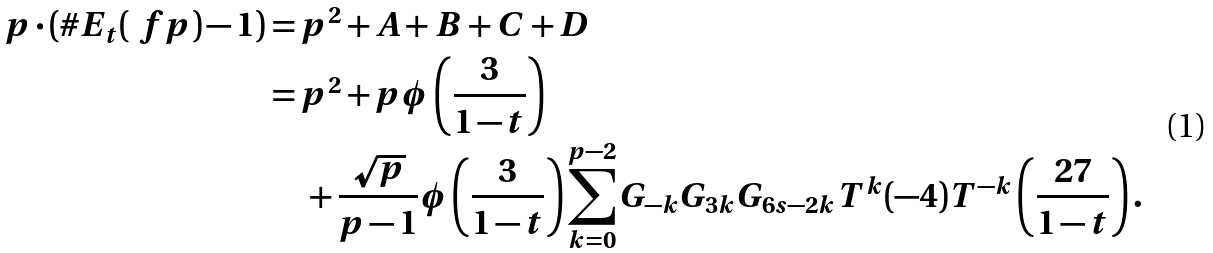Convert formula to latex. <formula><loc_0><loc_0><loc_500><loc_500>p \cdot ( \# E _ { t } ( \ f p ) - 1 ) & = p ^ { 2 } + A + B + C + D \\ & = p ^ { 2 } + p \phi \left ( \frac { 3 } { 1 - t } \right ) \\ & \, \quad + \frac { \sqrt { p } } { p - 1 } \phi \left ( \frac { 3 } { 1 - t } \right ) \sum _ { k = 0 } ^ { p - 2 } G _ { - k } G _ { 3 k } G _ { 6 s - 2 k } T ^ { k } ( - 4 ) T ^ { - k } \left ( \frac { 2 7 } { 1 - t } \right ) .</formula> 